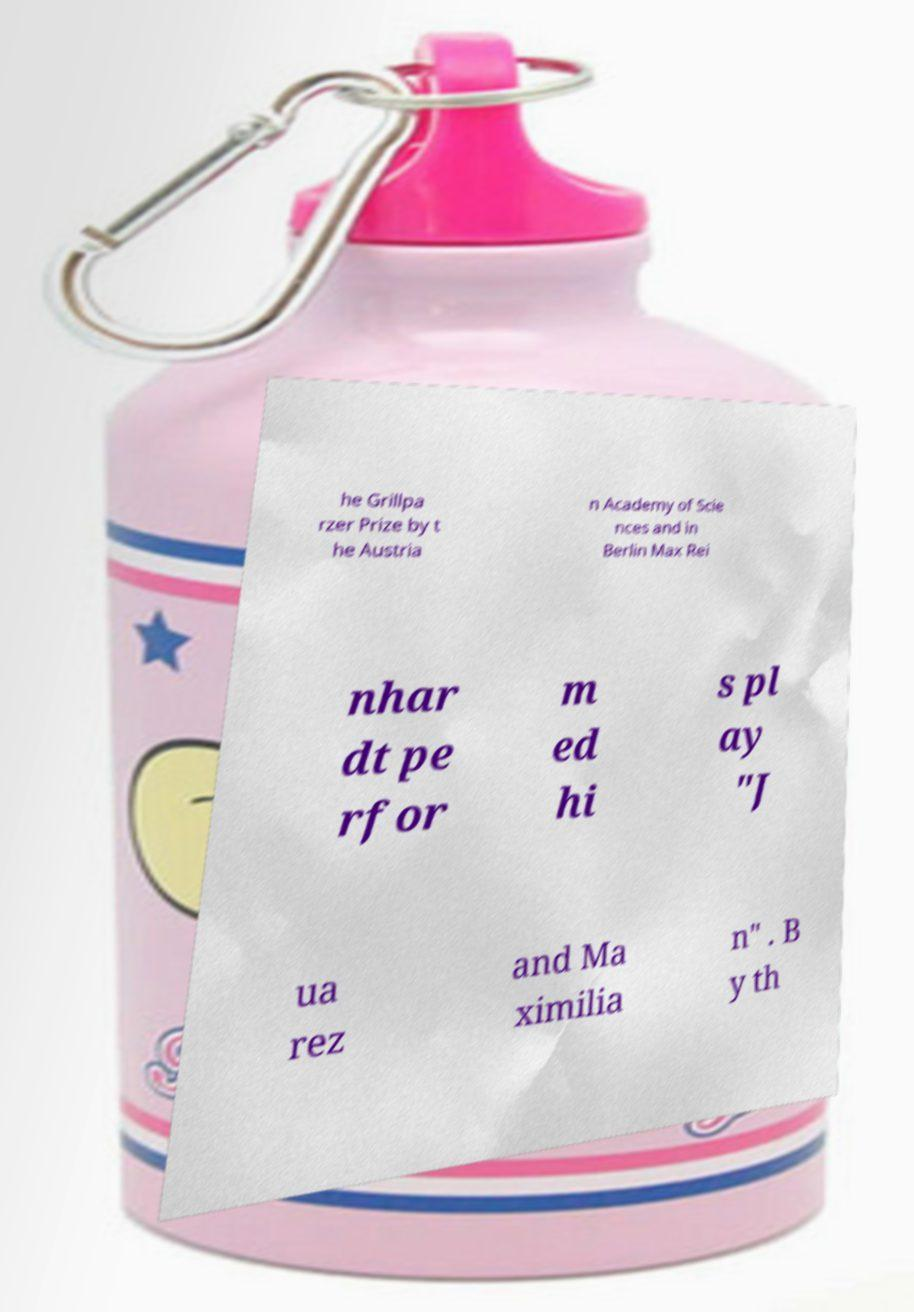Can you read and provide the text displayed in the image?This photo seems to have some interesting text. Can you extract and type it out for me? he Grillpa rzer Prize by t he Austria n Academy of Scie nces and in Berlin Max Rei nhar dt pe rfor m ed hi s pl ay "J ua rez and Ma ximilia n" . B y th 